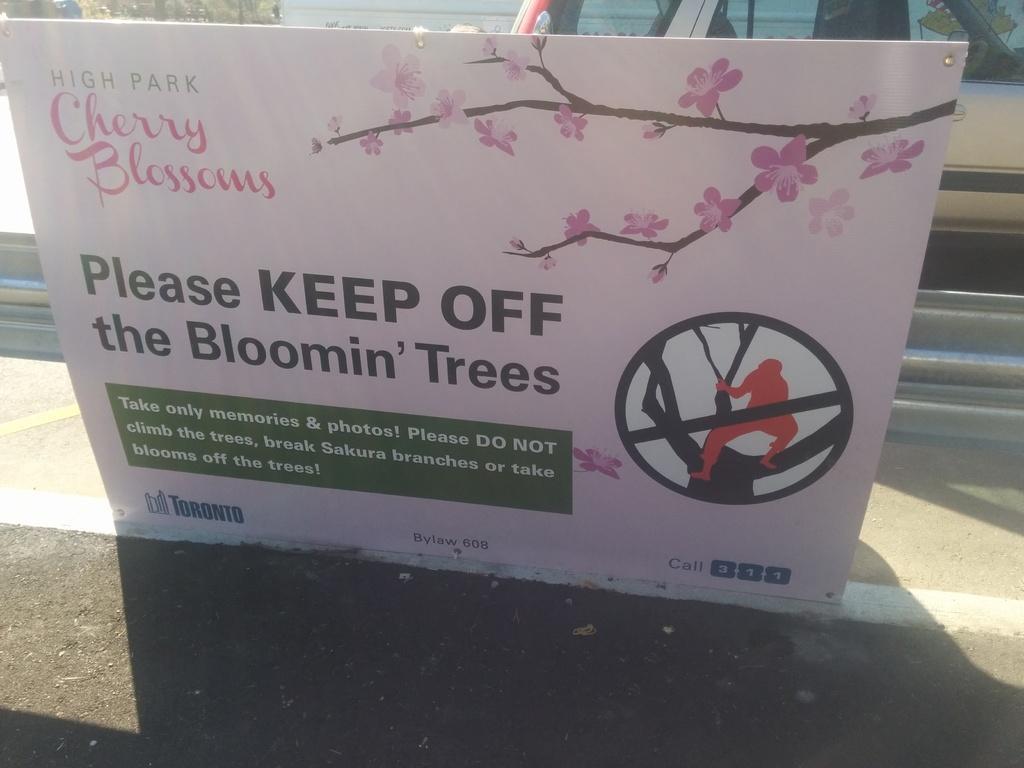Can you describe this image briefly? In the center of the image we can see one banner. On the banner, we can see some text. In the background, we can see one vehicle, fence and a few other objects. 